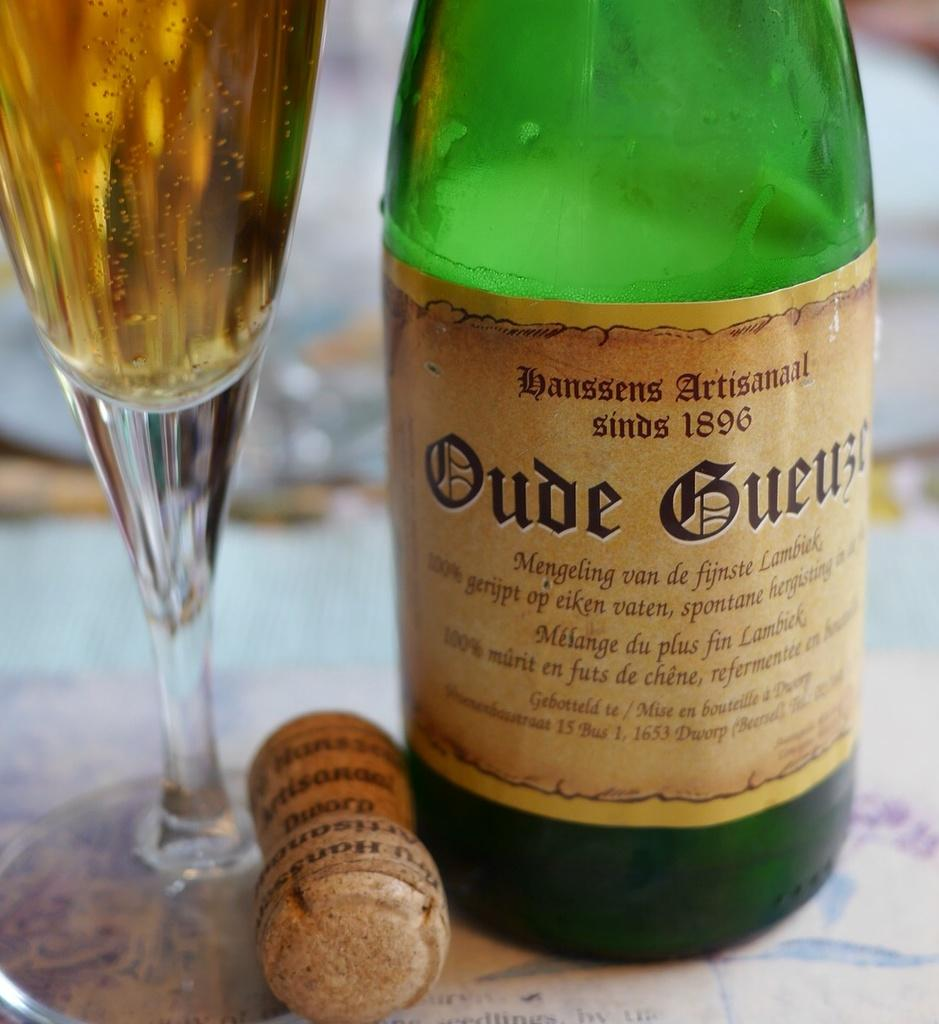Provide a one-sentence caption for the provided image. A bottle of a drink with the date 1896 on the label sits next to its cork. 